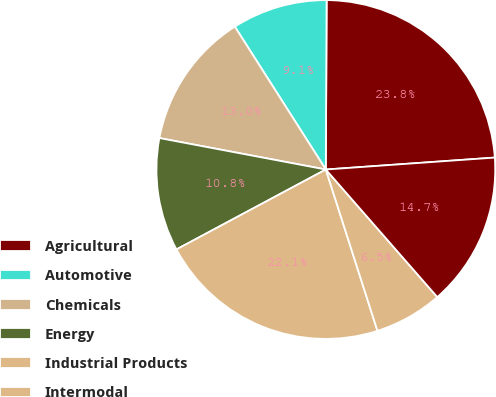Convert chart. <chart><loc_0><loc_0><loc_500><loc_500><pie_chart><fcel>Agricultural<fcel>Automotive<fcel>Chemicals<fcel>Energy<fcel>Industrial Products<fcel>Intermodal<fcel>Total<nl><fcel>23.8%<fcel>9.1%<fcel>13.0%<fcel>10.79%<fcel>22.11%<fcel>6.5%<fcel>14.69%<nl></chart> 